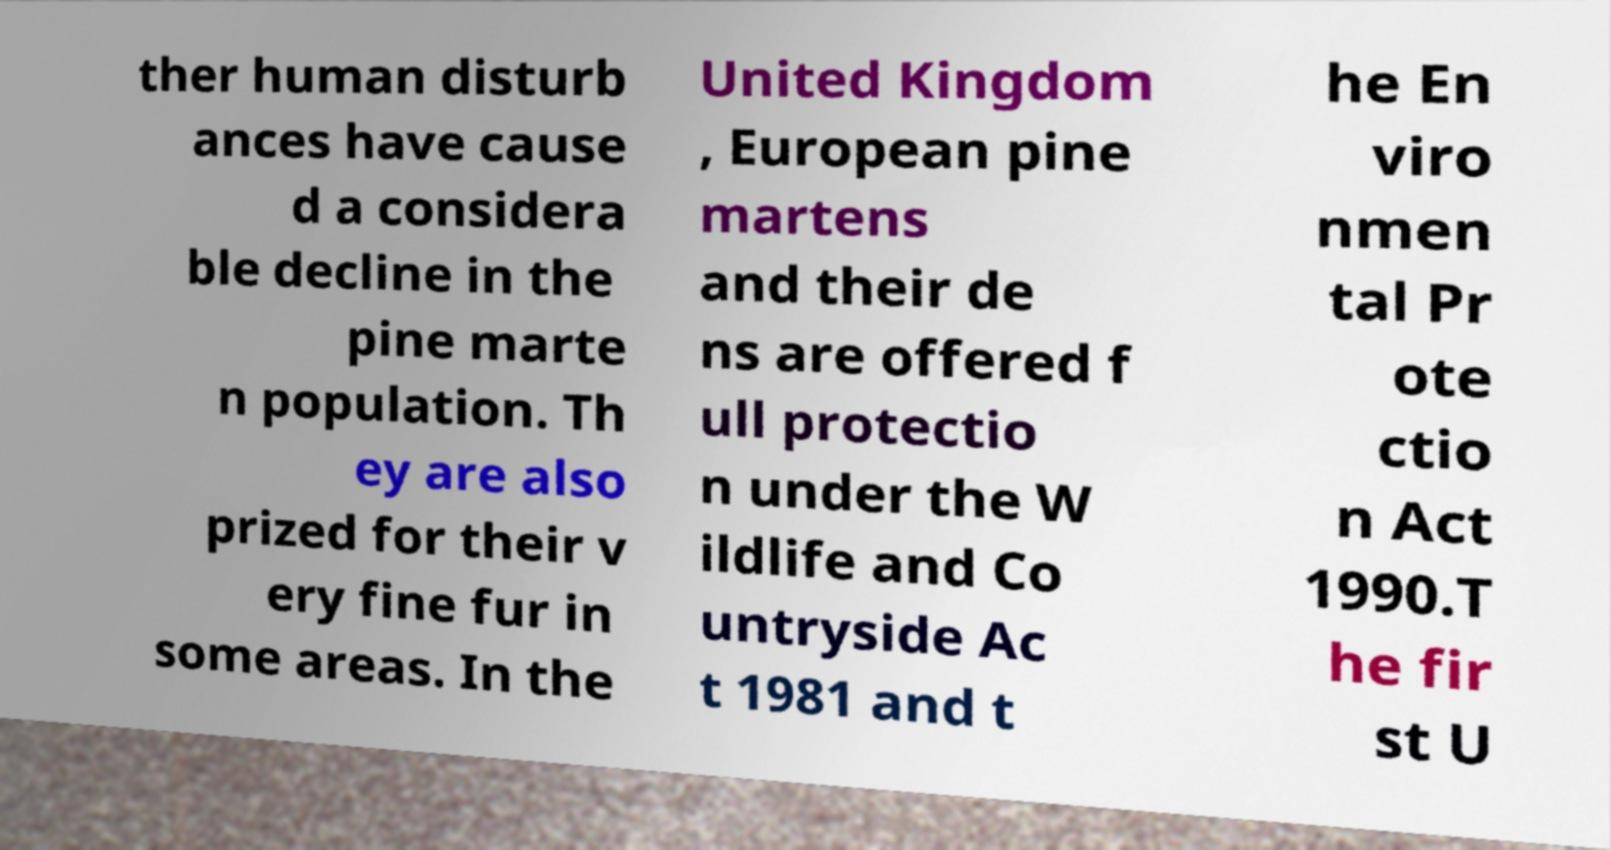For documentation purposes, I need the text within this image transcribed. Could you provide that? ther human disturb ances have cause d a considera ble decline in the pine marte n population. Th ey are also prized for their v ery fine fur in some areas. In the United Kingdom , European pine martens and their de ns are offered f ull protectio n under the W ildlife and Co untryside Ac t 1981 and t he En viro nmen tal Pr ote ctio n Act 1990.T he fir st U 